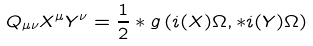Convert formula to latex. <formula><loc_0><loc_0><loc_500><loc_500>{ Q } _ { \mu \nu } X ^ { \mu } Y ^ { \nu } = \frac { 1 } { 2 } * g \left ( i ( X ) \Omega , * i ( Y ) \Omega \right )</formula> 